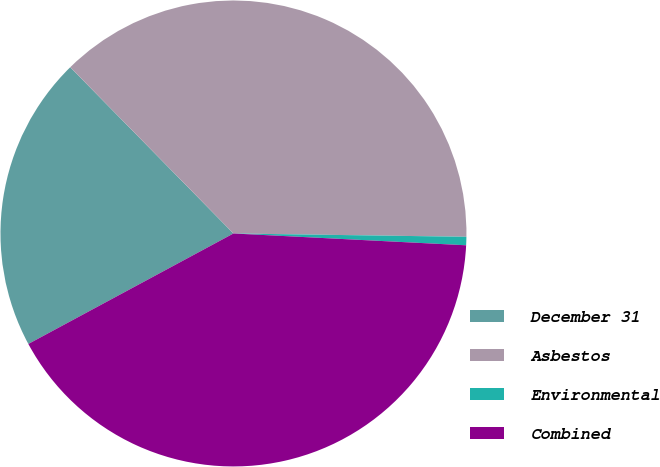Convert chart. <chart><loc_0><loc_0><loc_500><loc_500><pie_chart><fcel>December 31<fcel>Asbestos<fcel>Environmental<fcel>Combined<nl><fcel>20.51%<fcel>37.58%<fcel>0.58%<fcel>41.33%<nl></chart> 